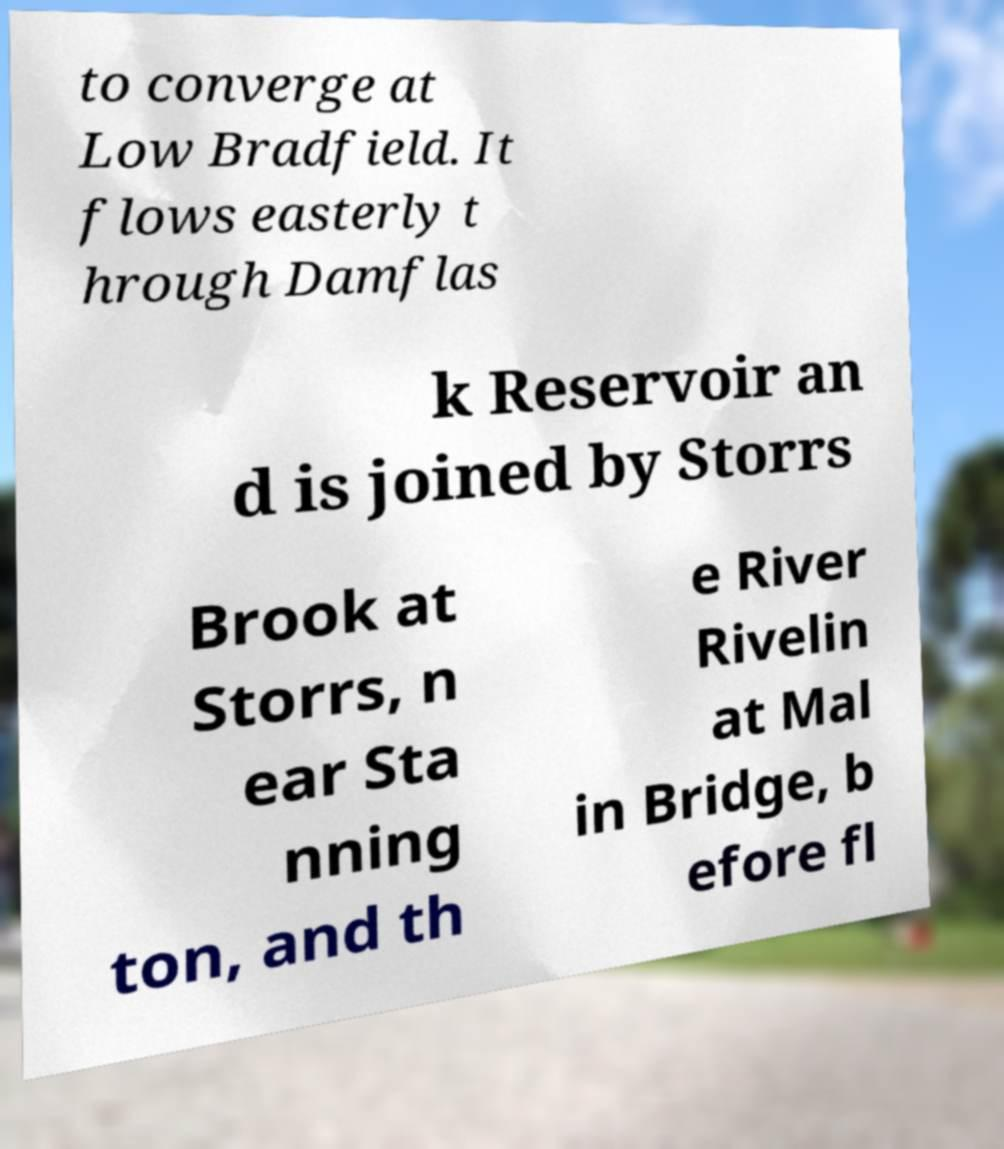Can you read and provide the text displayed in the image?This photo seems to have some interesting text. Can you extract and type it out for me? to converge at Low Bradfield. It flows easterly t hrough Damflas k Reservoir an d is joined by Storrs Brook at Storrs, n ear Sta nning ton, and th e River Rivelin at Mal in Bridge, b efore fl 